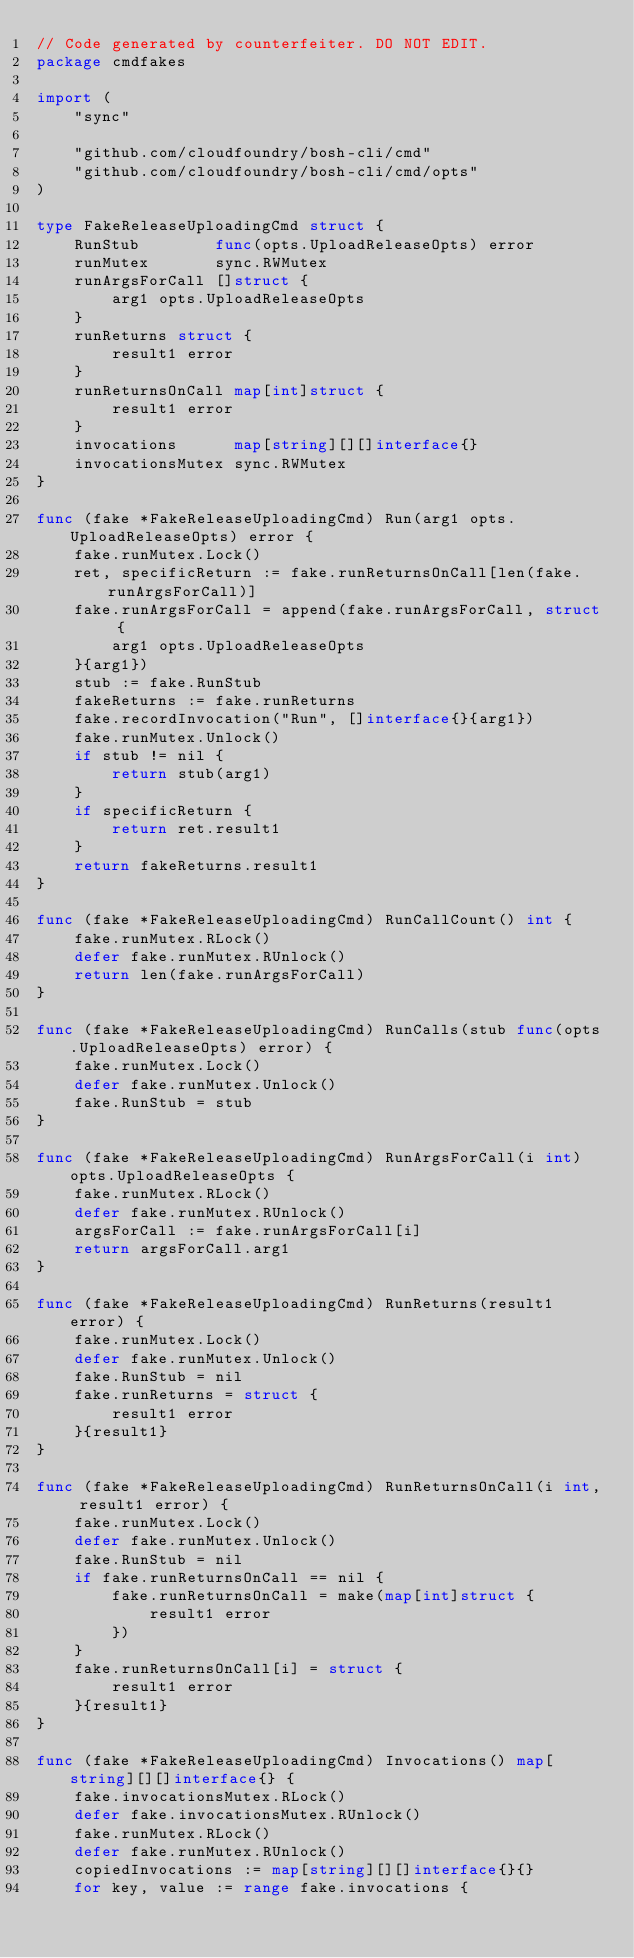Convert code to text. <code><loc_0><loc_0><loc_500><loc_500><_Go_>// Code generated by counterfeiter. DO NOT EDIT.
package cmdfakes

import (
	"sync"

	"github.com/cloudfoundry/bosh-cli/cmd"
	"github.com/cloudfoundry/bosh-cli/cmd/opts"
)

type FakeReleaseUploadingCmd struct {
	RunStub        func(opts.UploadReleaseOpts) error
	runMutex       sync.RWMutex
	runArgsForCall []struct {
		arg1 opts.UploadReleaseOpts
	}
	runReturns struct {
		result1 error
	}
	runReturnsOnCall map[int]struct {
		result1 error
	}
	invocations      map[string][][]interface{}
	invocationsMutex sync.RWMutex
}

func (fake *FakeReleaseUploadingCmd) Run(arg1 opts.UploadReleaseOpts) error {
	fake.runMutex.Lock()
	ret, specificReturn := fake.runReturnsOnCall[len(fake.runArgsForCall)]
	fake.runArgsForCall = append(fake.runArgsForCall, struct {
		arg1 opts.UploadReleaseOpts
	}{arg1})
	stub := fake.RunStub
	fakeReturns := fake.runReturns
	fake.recordInvocation("Run", []interface{}{arg1})
	fake.runMutex.Unlock()
	if stub != nil {
		return stub(arg1)
	}
	if specificReturn {
		return ret.result1
	}
	return fakeReturns.result1
}

func (fake *FakeReleaseUploadingCmd) RunCallCount() int {
	fake.runMutex.RLock()
	defer fake.runMutex.RUnlock()
	return len(fake.runArgsForCall)
}

func (fake *FakeReleaseUploadingCmd) RunCalls(stub func(opts.UploadReleaseOpts) error) {
	fake.runMutex.Lock()
	defer fake.runMutex.Unlock()
	fake.RunStub = stub
}

func (fake *FakeReleaseUploadingCmd) RunArgsForCall(i int) opts.UploadReleaseOpts {
	fake.runMutex.RLock()
	defer fake.runMutex.RUnlock()
	argsForCall := fake.runArgsForCall[i]
	return argsForCall.arg1
}

func (fake *FakeReleaseUploadingCmd) RunReturns(result1 error) {
	fake.runMutex.Lock()
	defer fake.runMutex.Unlock()
	fake.RunStub = nil
	fake.runReturns = struct {
		result1 error
	}{result1}
}

func (fake *FakeReleaseUploadingCmd) RunReturnsOnCall(i int, result1 error) {
	fake.runMutex.Lock()
	defer fake.runMutex.Unlock()
	fake.RunStub = nil
	if fake.runReturnsOnCall == nil {
		fake.runReturnsOnCall = make(map[int]struct {
			result1 error
		})
	}
	fake.runReturnsOnCall[i] = struct {
		result1 error
	}{result1}
}

func (fake *FakeReleaseUploadingCmd) Invocations() map[string][][]interface{} {
	fake.invocationsMutex.RLock()
	defer fake.invocationsMutex.RUnlock()
	fake.runMutex.RLock()
	defer fake.runMutex.RUnlock()
	copiedInvocations := map[string][][]interface{}{}
	for key, value := range fake.invocations {</code> 